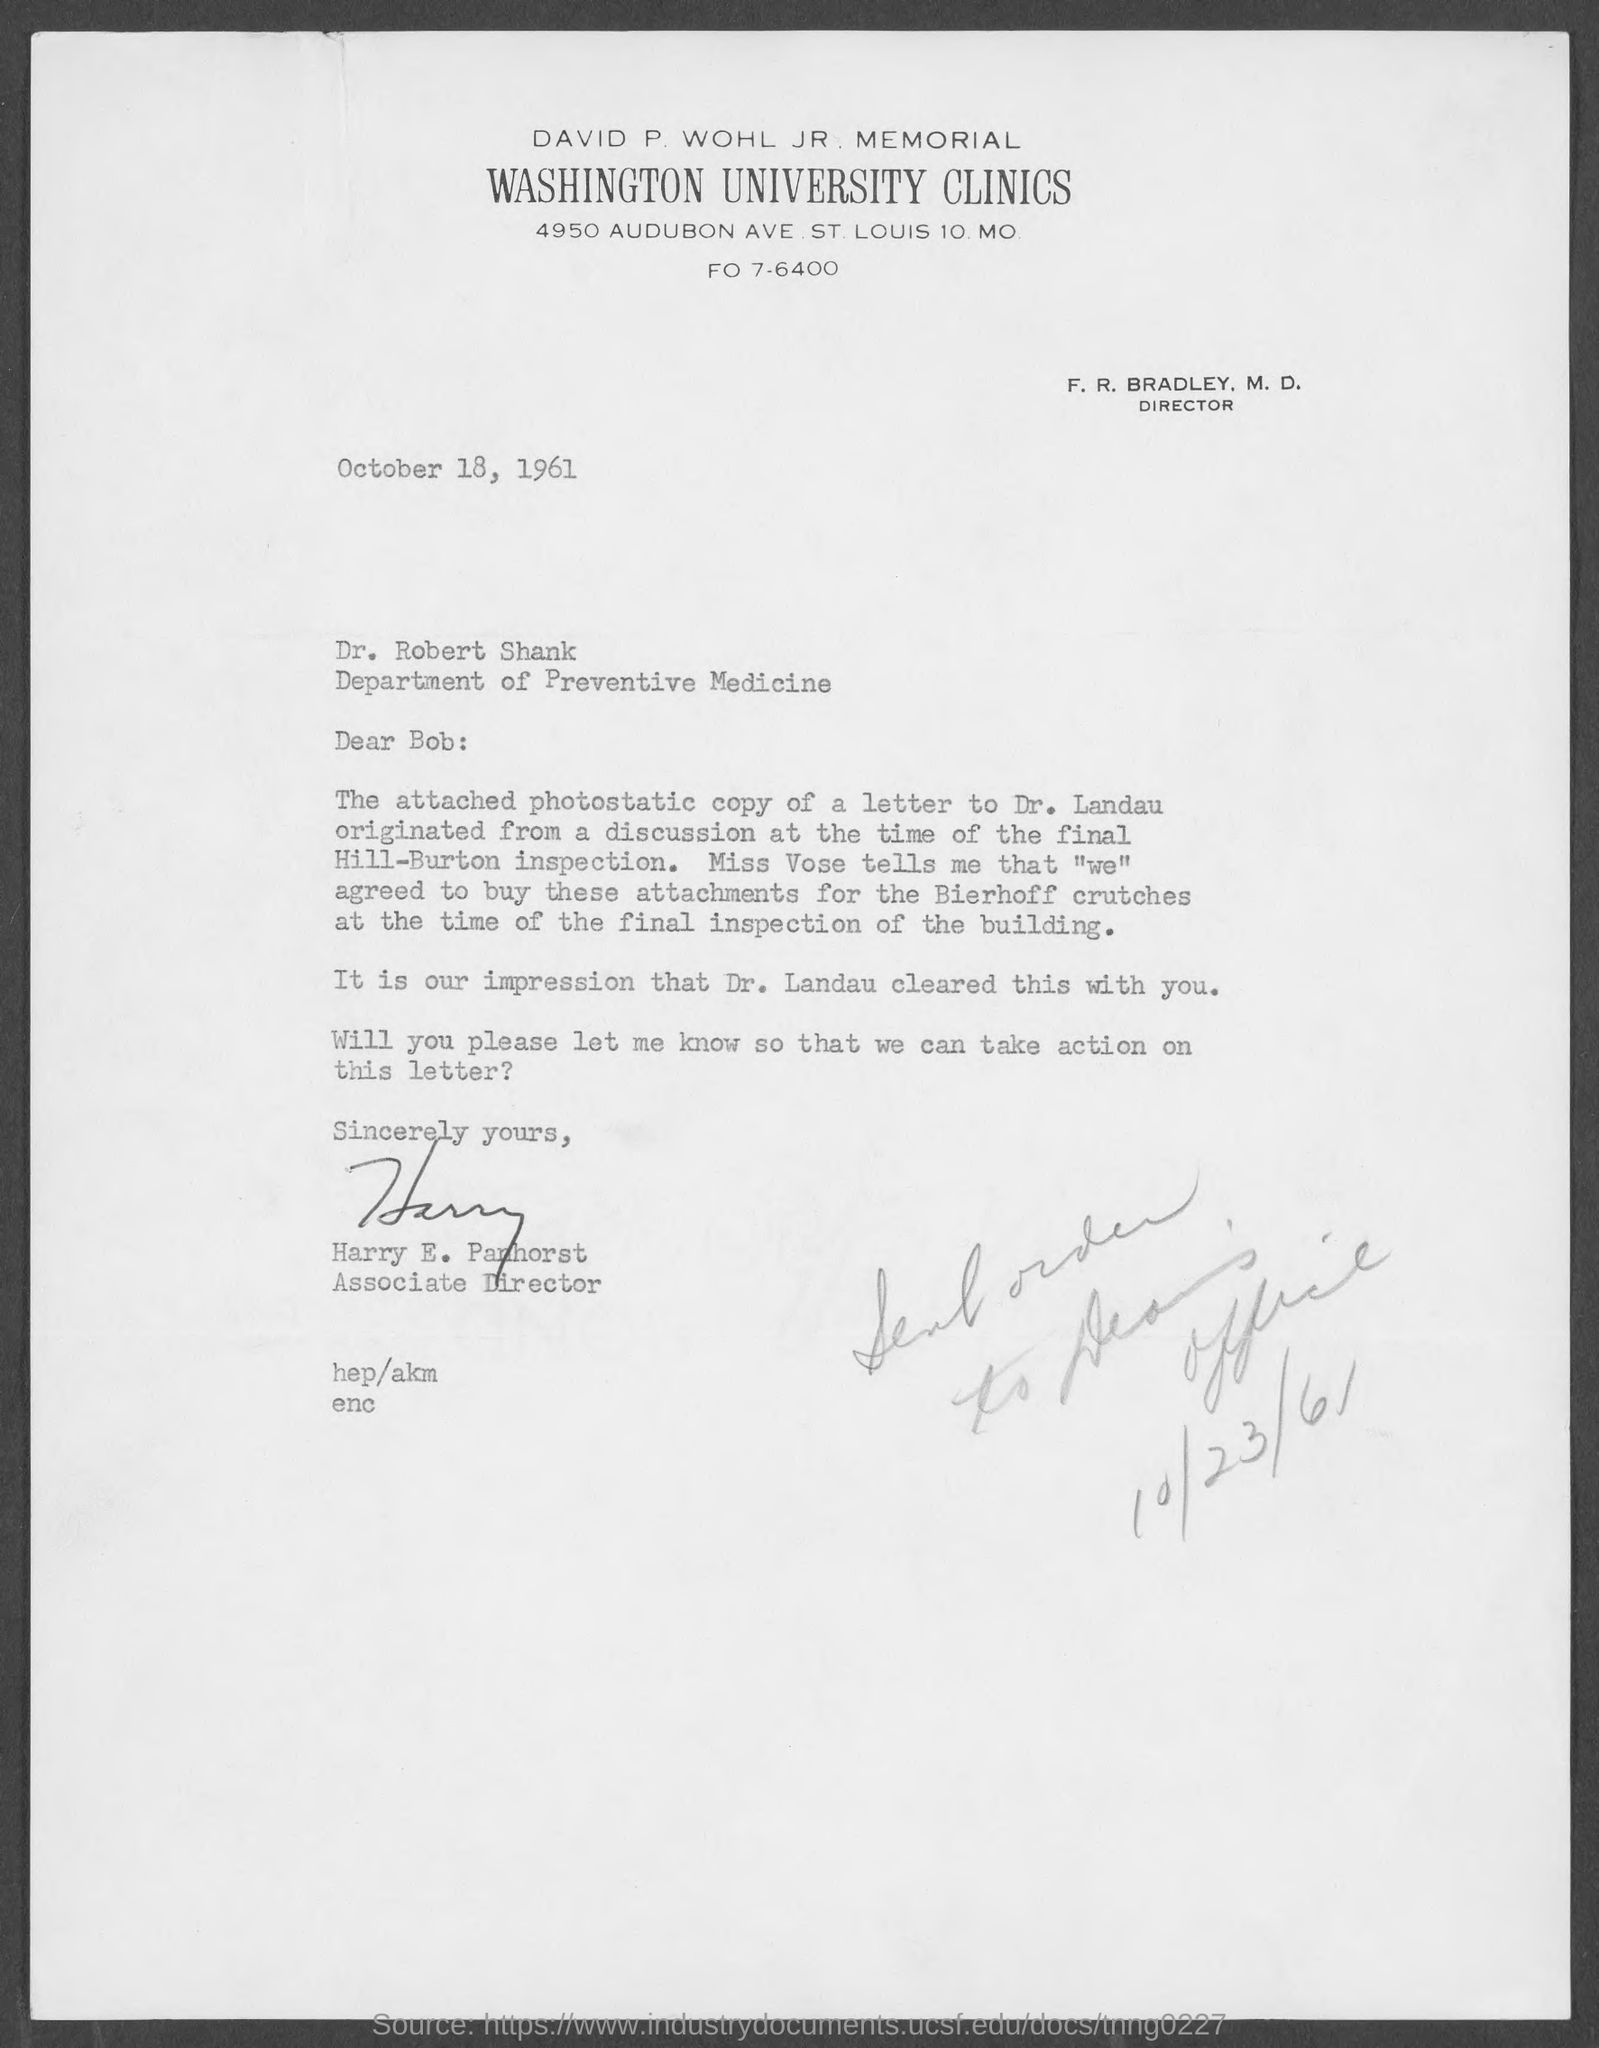Specify some key components in this picture. The Associate Director of the Washington University Clinics is Harry E. Panhorst. The address of Washington University Clinics is 4950 Audubon Avenue in St. Louis, Missouri, 10. Dr. Robert Shank belongs to the Department of Preventive Medicine. 